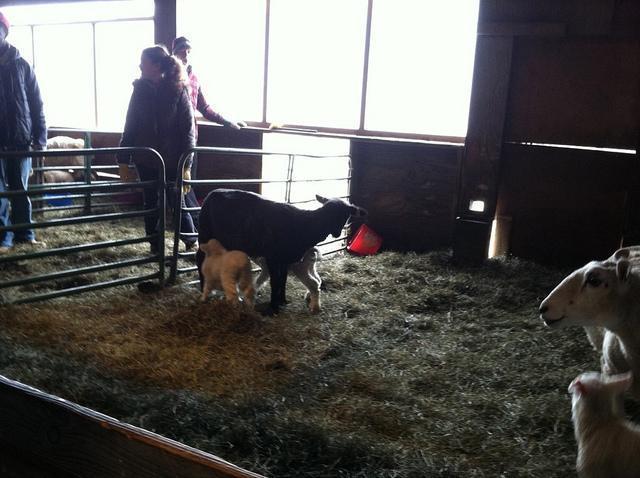How many sheep are in the picture?
Give a very brief answer. 4. How many people are there?
Give a very brief answer. 2. How many cows are there?
Give a very brief answer. 0. 